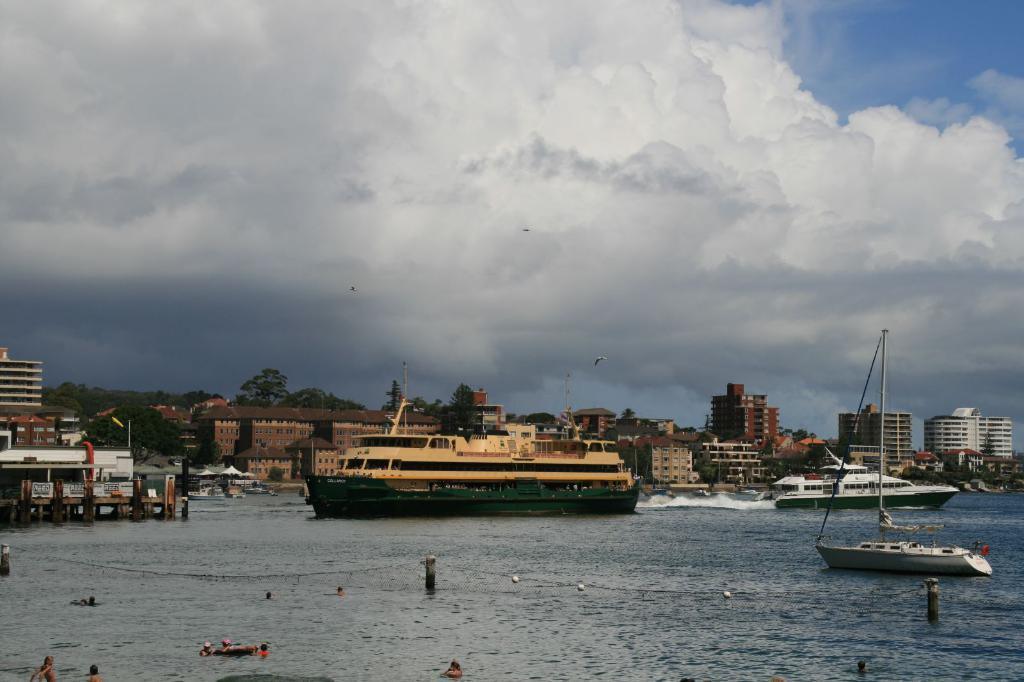What is the main subject of the image? The main subject of the image is ships. Where are the ships located? The ships are on the water. What can be seen in the background of the image? There are buildings and trees in the background of the image. What is visible at the top of the image? The sky is visible at the top of the image. What type of rake is being used to maintain the trees in the image? There is no rake present in the image; it features ships on the water with buildings and trees in the background. 